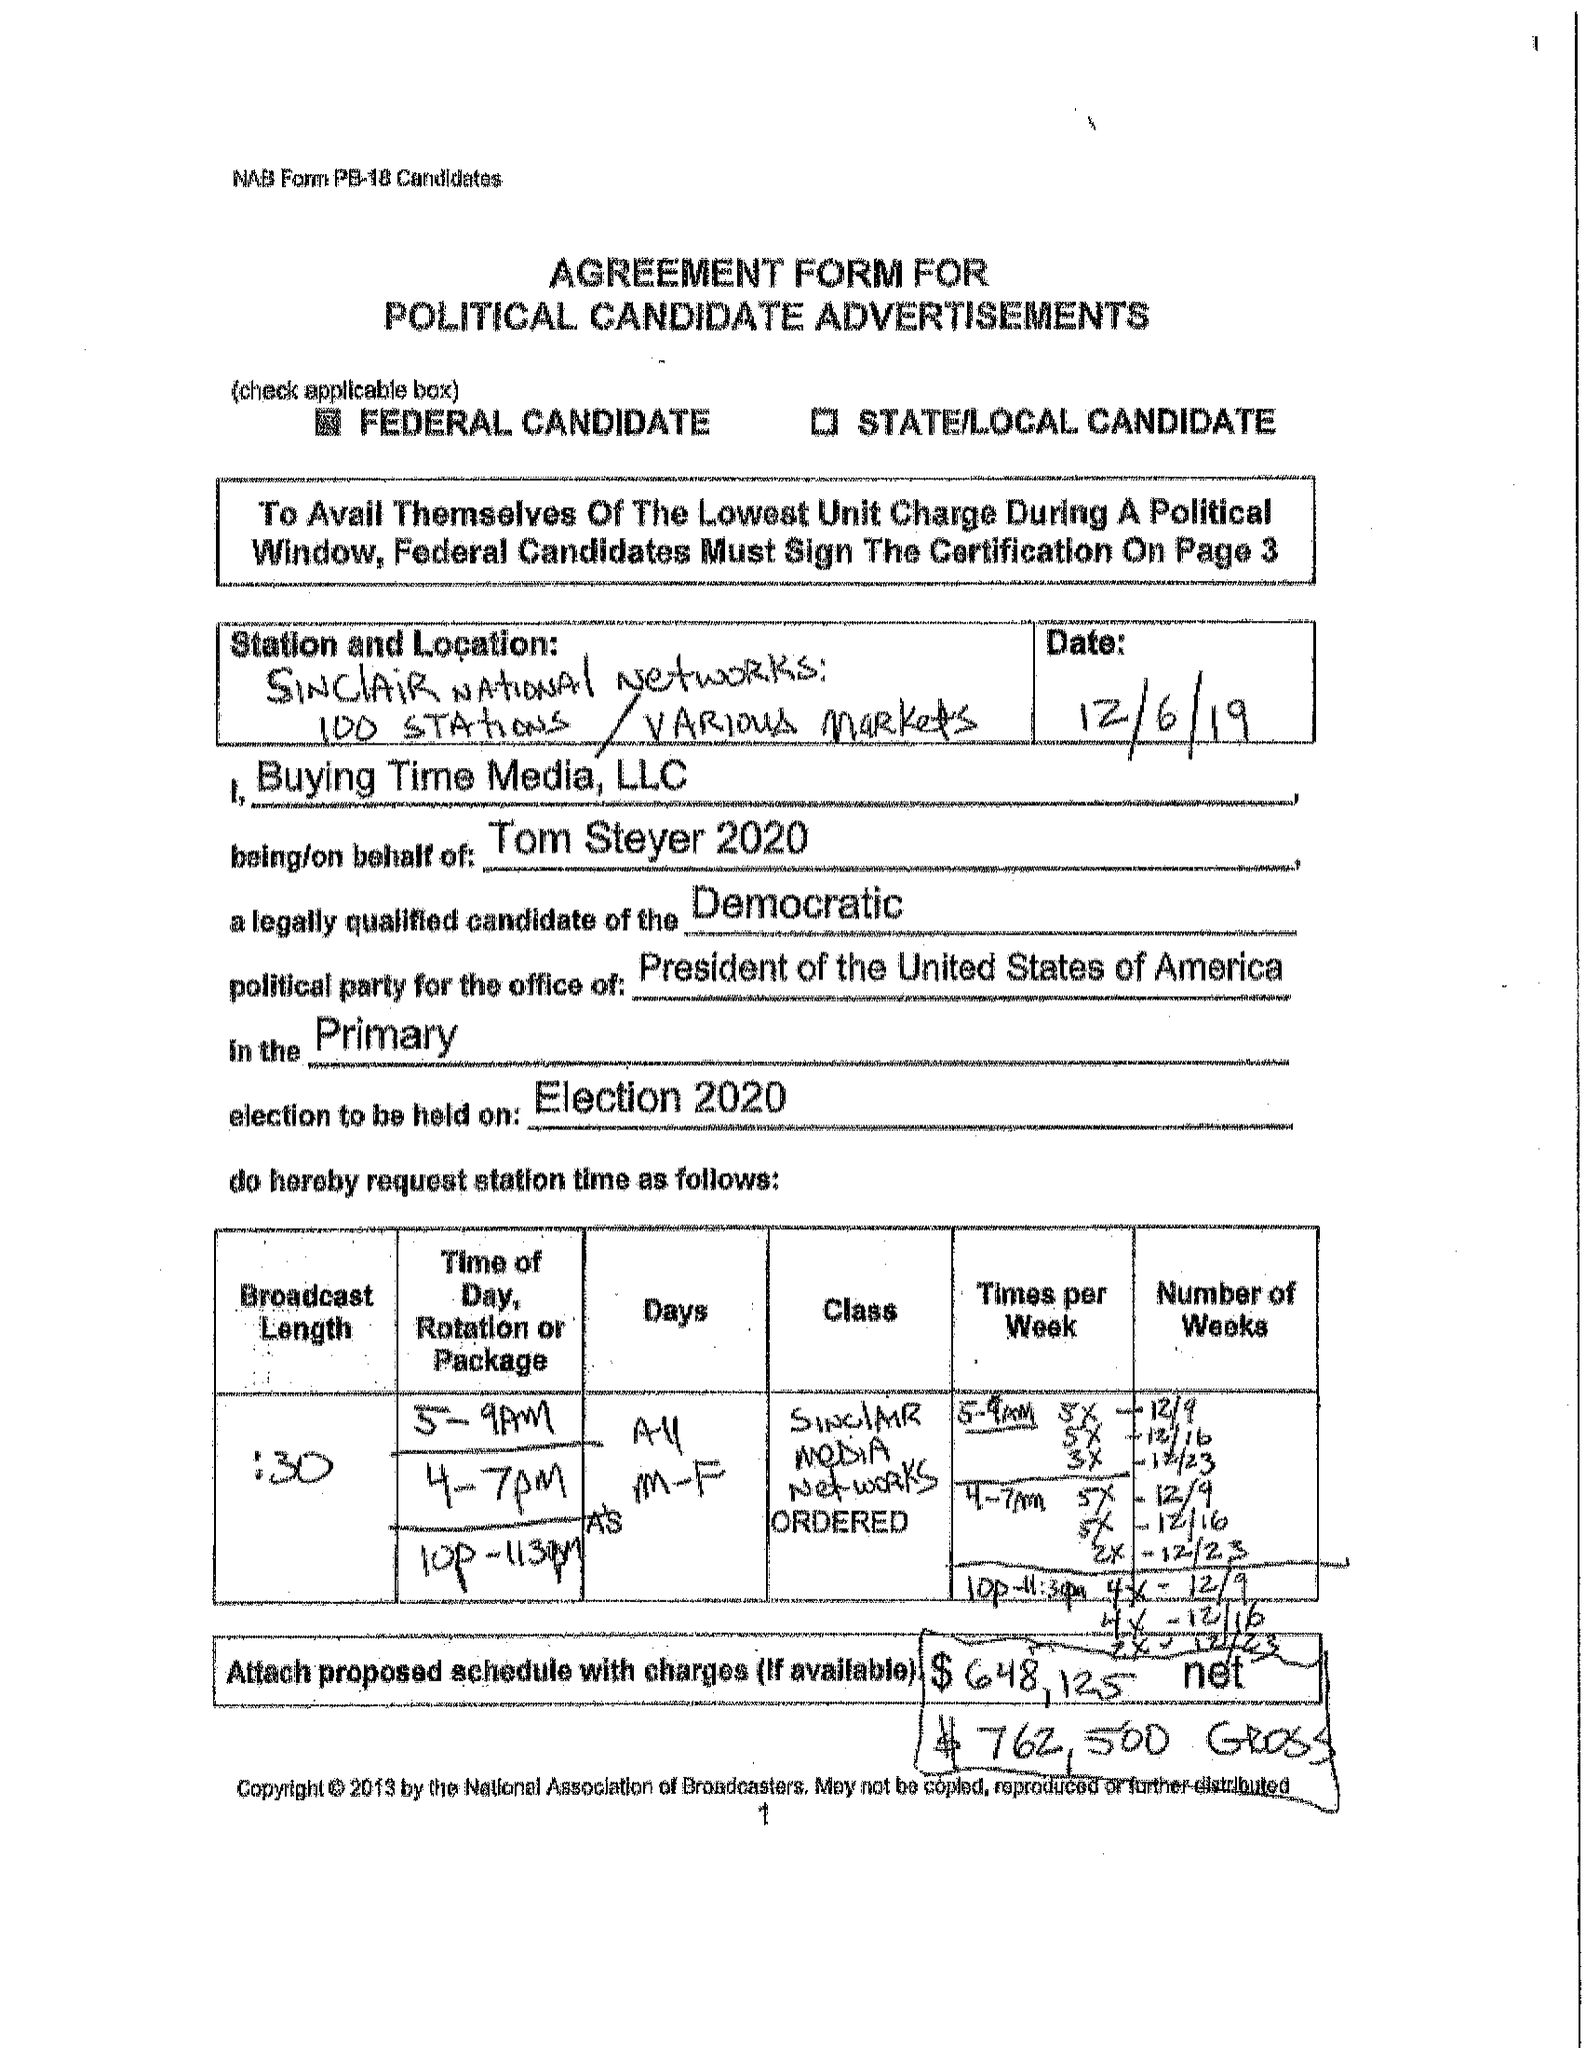What is the value for the advertiser?
Answer the question using a single word or phrase. TOM STEYER FOR PRESIDENT 